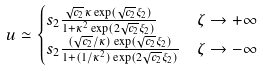<formula> <loc_0><loc_0><loc_500><loc_500>& u \simeq \begin{cases} s _ { 2 } \frac { \sqrt { c _ { 2 } } \kappa \exp ( \sqrt { c _ { 2 } } \xi _ { 2 } ) } { 1 + \kappa ^ { 2 } \exp ( 2 \sqrt { c _ { 2 } } \xi _ { 2 } ) } & \zeta \rightarrow + \infty \\ s _ { 2 } \frac { ( \sqrt { c _ { 2 } } / \kappa ) \exp ( \sqrt { c _ { 2 } } \xi _ { 2 } ) } { 1 + ( 1 / \kappa ^ { 2 } ) \exp ( 2 \sqrt { c _ { 2 } } \xi _ { 2 } ) } & \zeta \rightarrow - \infty \end{cases}</formula> 